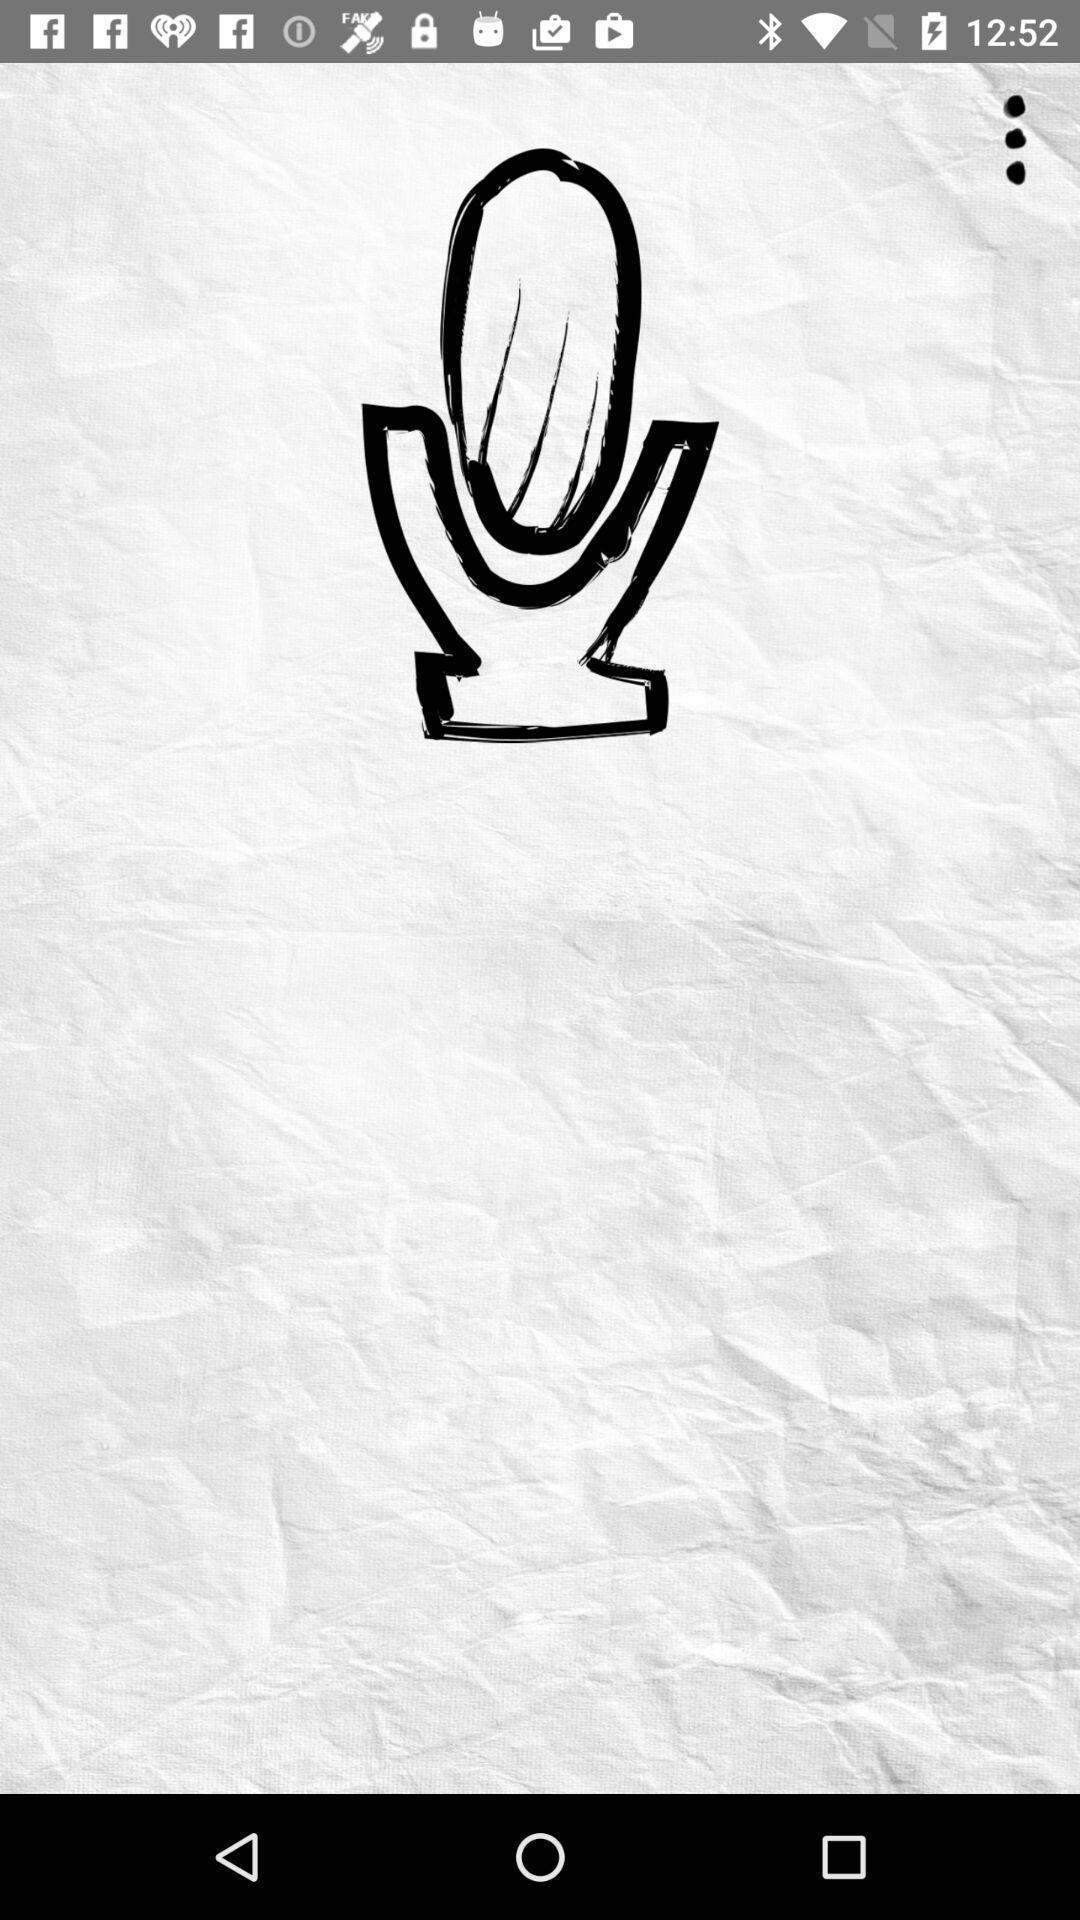Explain the elements present in this screenshot. Page displaying mic in backwards words challenge app. 